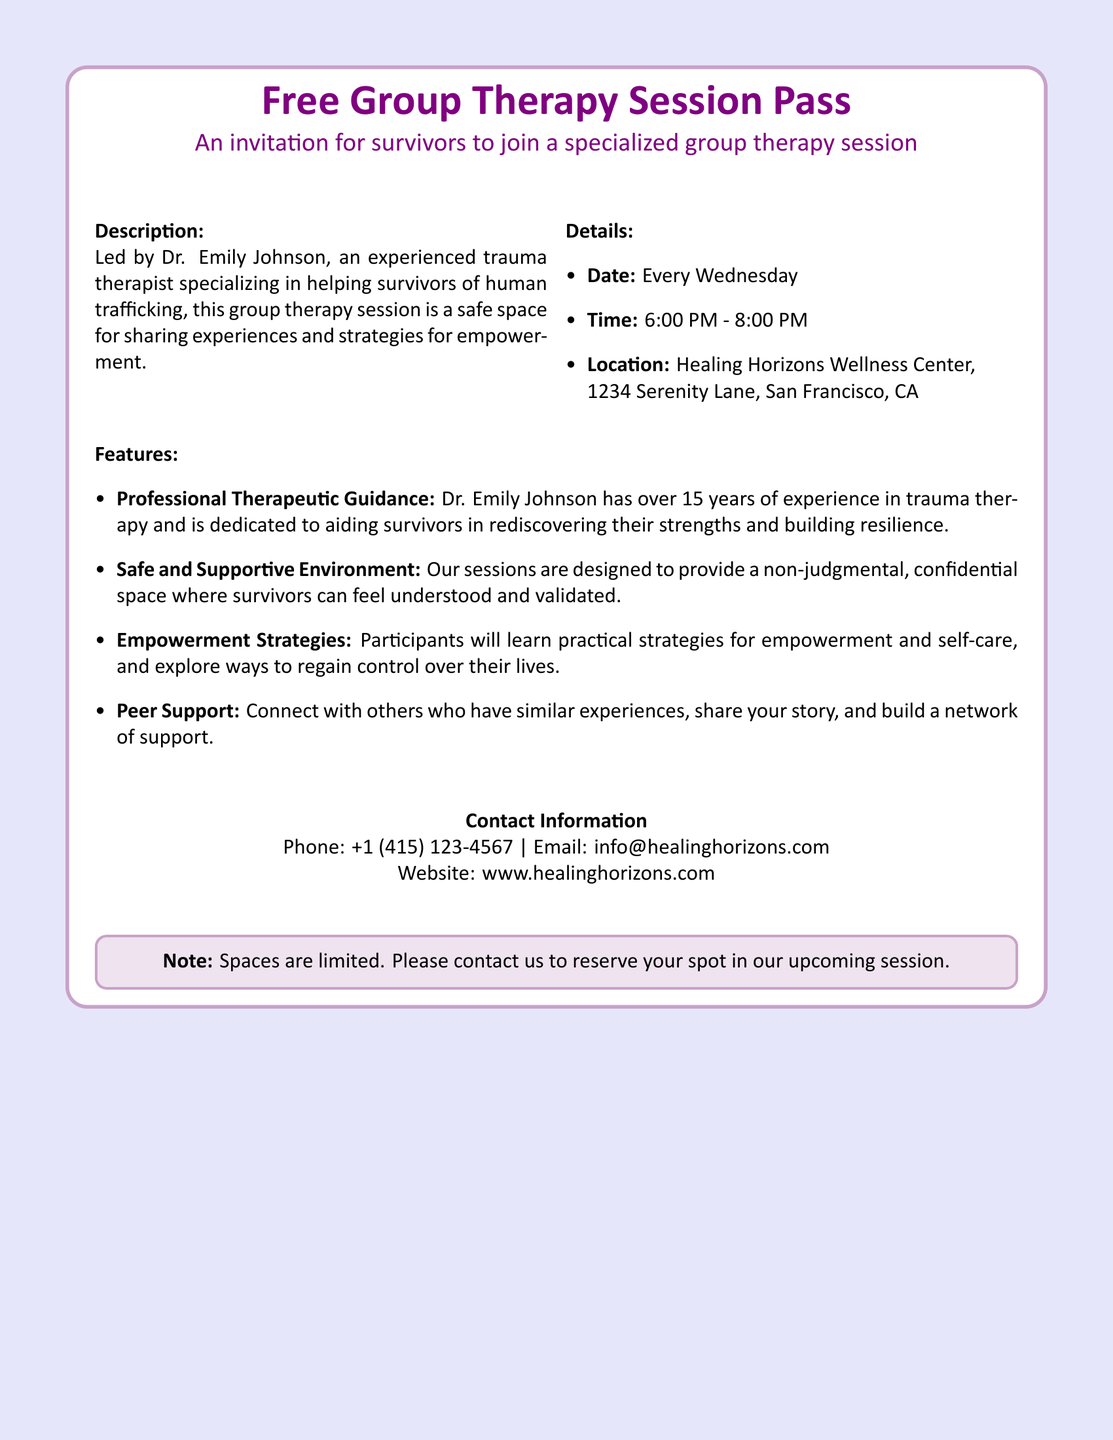What is the therapist's name? The therapist leading the session is Dr. Emily Johnson, as mentioned in the document.
Answer: Dr. Emily Johnson What day of the week does the session occur? The document states that the sessions are held every Wednesday.
Answer: Wednesday What time do the sessions start? The starting time for the sessions is provided in the document as 6:00 PM.
Answer: 6:00 PM How many years of experience does Dr. Johnson have? The document mentions that Dr. Emily Johnson has over 15 years of experience in trauma therapy.
Answer: 15 years What is the address of the healing center? The address for the Healing Horizons Wellness Center is listed in the document.
Answer: 1234 Serenity Lane, San Francisco, CA What does participation help survivors to learn? The document highlights that participants will learn practical strategies for empowerment and self-care.
Answer: Empowerment and self-care What type of environment is provided during the sessions? According to the document, the sessions are designed to provide a non-judgmental, confidential space.
Answer: Non-judgmental, confidential space How can participants reserve a spot? The document advises participants to contact the organization in order to reserve their spot.
Answer: Contact us What is the phone number for contacting the center? The document includes a phone number for inquiries, which is listed in the contact information.
Answer: +1 (415) 123-4567 